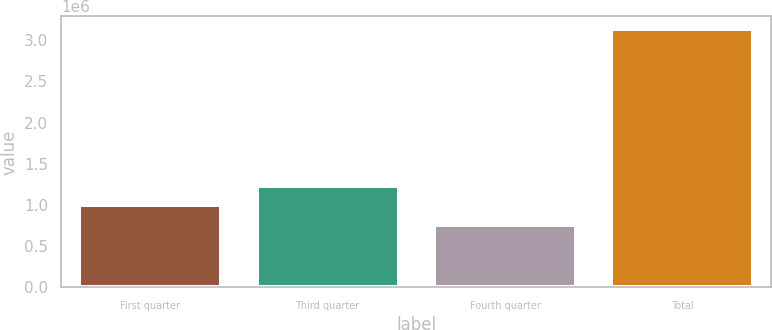<chart> <loc_0><loc_0><loc_500><loc_500><bar_chart><fcel>First quarter<fcel>Third quarter<fcel>Fourth quarter<fcel>Total<nl><fcel>994869<fcel>1.2325e+06<fcel>757235<fcel>3.13358e+06<nl></chart> 